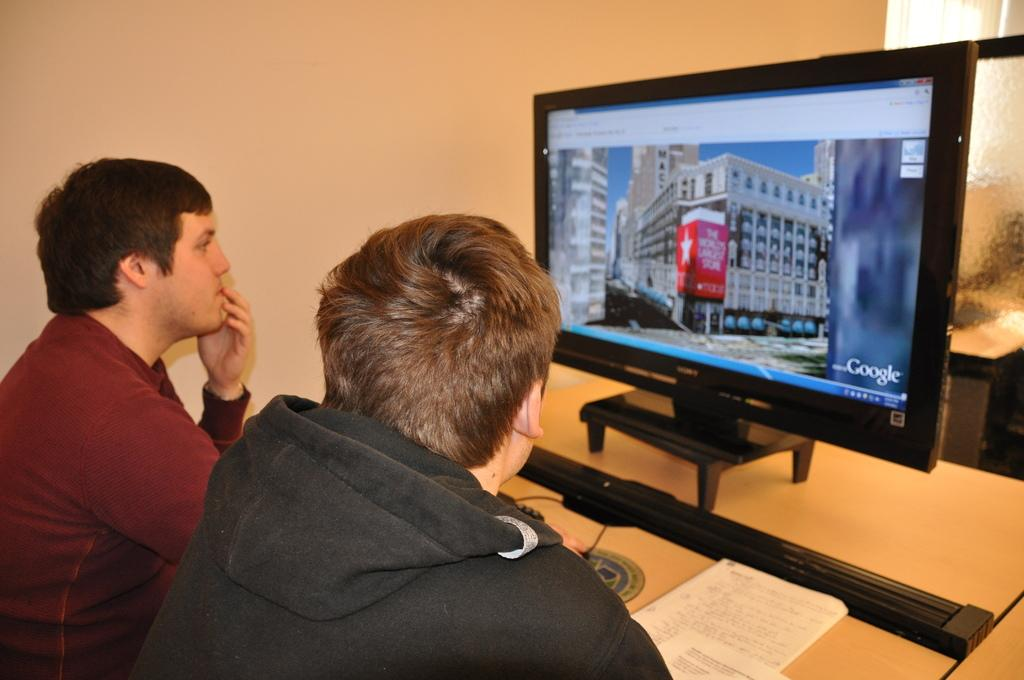<image>
Render a clear and concise summary of the photo. The guys are using Google while looking at a picture on a monitor. 